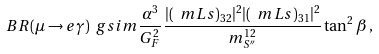<formula> <loc_0><loc_0><loc_500><loc_500>B R ( \mu \rightarrow e \gamma ) \ g s i m \frac { \alpha ^ { 3 } } { G _ { F } ^ { 2 } } \frac { | ( \ m L s ) _ { 3 2 } | ^ { 2 } | ( \ m L s ) _ { 3 1 } | ^ { 2 } } { m _ { S ^ { \prime \prime } } ^ { 1 2 } } \tan ^ { 2 } \beta \, ,</formula> 